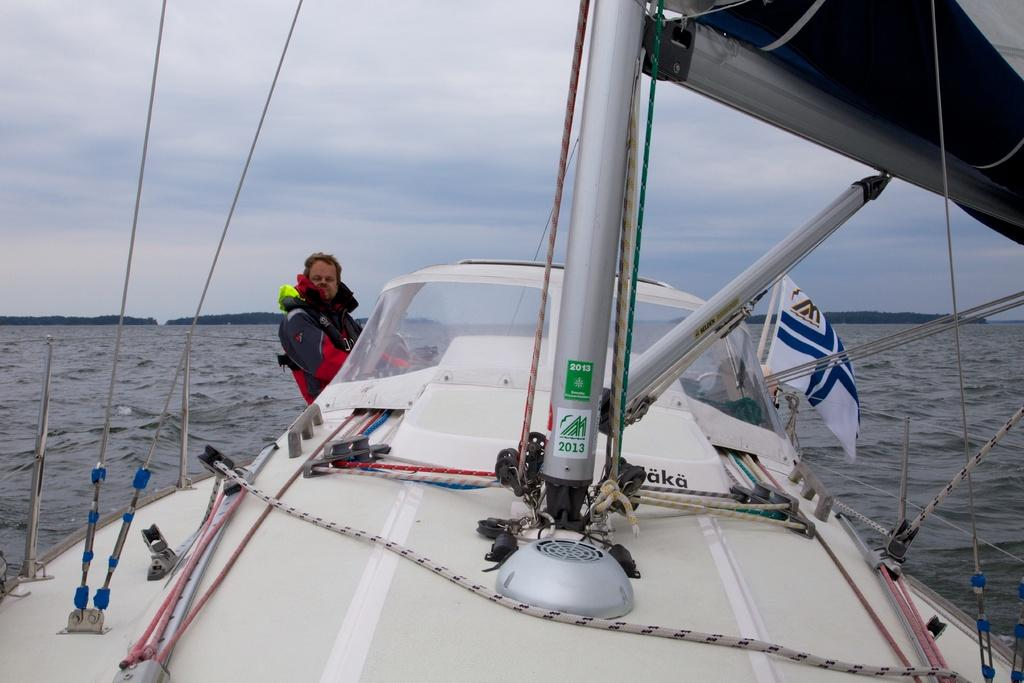What type of vehicle is in the image? There is a white ship in the image. Where is the ship located? The ship is on the water. Can you describe anything about the people in the image? A person is present on the left side of the image. What is attached to the ship on the right side? A flag is present on the right side of the image. How many rooms are there in the ship? There are many rooms in the ship. How many ants are crawling on the ship in the image? There are no ants present in the image; it features a white ship on the water. What type of magic is being performed on the ship in the image? There is no magic being performed in the image; it is a realistic depiction of a ship on the water. 